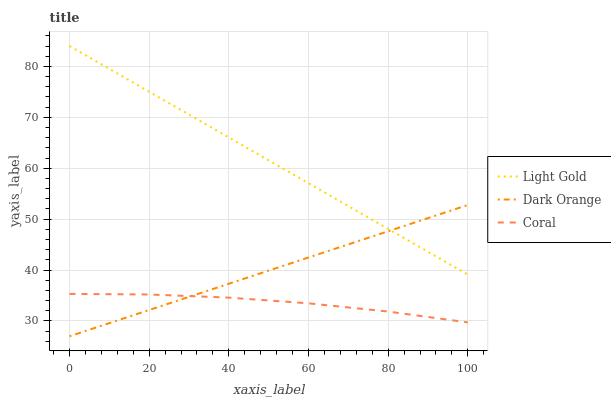Does Coral have the minimum area under the curve?
Answer yes or no. Yes. Does Light Gold have the maximum area under the curve?
Answer yes or no. Yes. Does Light Gold have the minimum area under the curve?
Answer yes or no. No. Does Coral have the maximum area under the curve?
Answer yes or no. No. Is Dark Orange the smoothest?
Answer yes or no. Yes. Is Coral the roughest?
Answer yes or no. Yes. Is Light Gold the smoothest?
Answer yes or no. No. Is Light Gold the roughest?
Answer yes or no. No. Does Coral have the lowest value?
Answer yes or no. No. Does Light Gold have the highest value?
Answer yes or no. Yes. Does Coral have the highest value?
Answer yes or no. No. Is Coral less than Light Gold?
Answer yes or no. Yes. Is Light Gold greater than Coral?
Answer yes or no. Yes. Does Coral intersect Dark Orange?
Answer yes or no. Yes. Is Coral less than Dark Orange?
Answer yes or no. No. Is Coral greater than Dark Orange?
Answer yes or no. No. Does Coral intersect Light Gold?
Answer yes or no. No. 